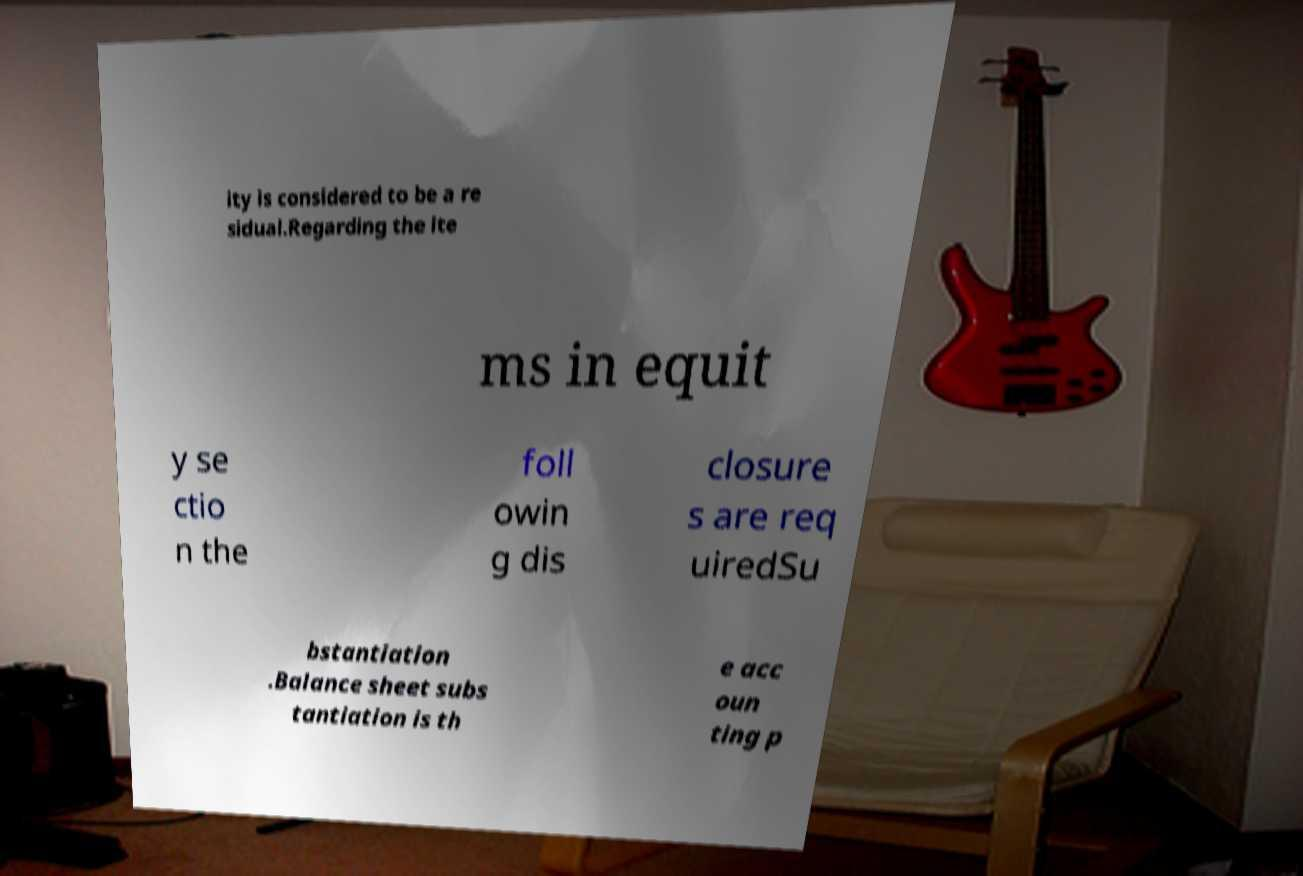Can you read and provide the text displayed in the image?This photo seems to have some interesting text. Can you extract and type it out for me? ity is considered to be a re sidual.Regarding the ite ms in equit y se ctio n the foll owin g dis closure s are req uiredSu bstantiation .Balance sheet subs tantiation is th e acc oun ting p 